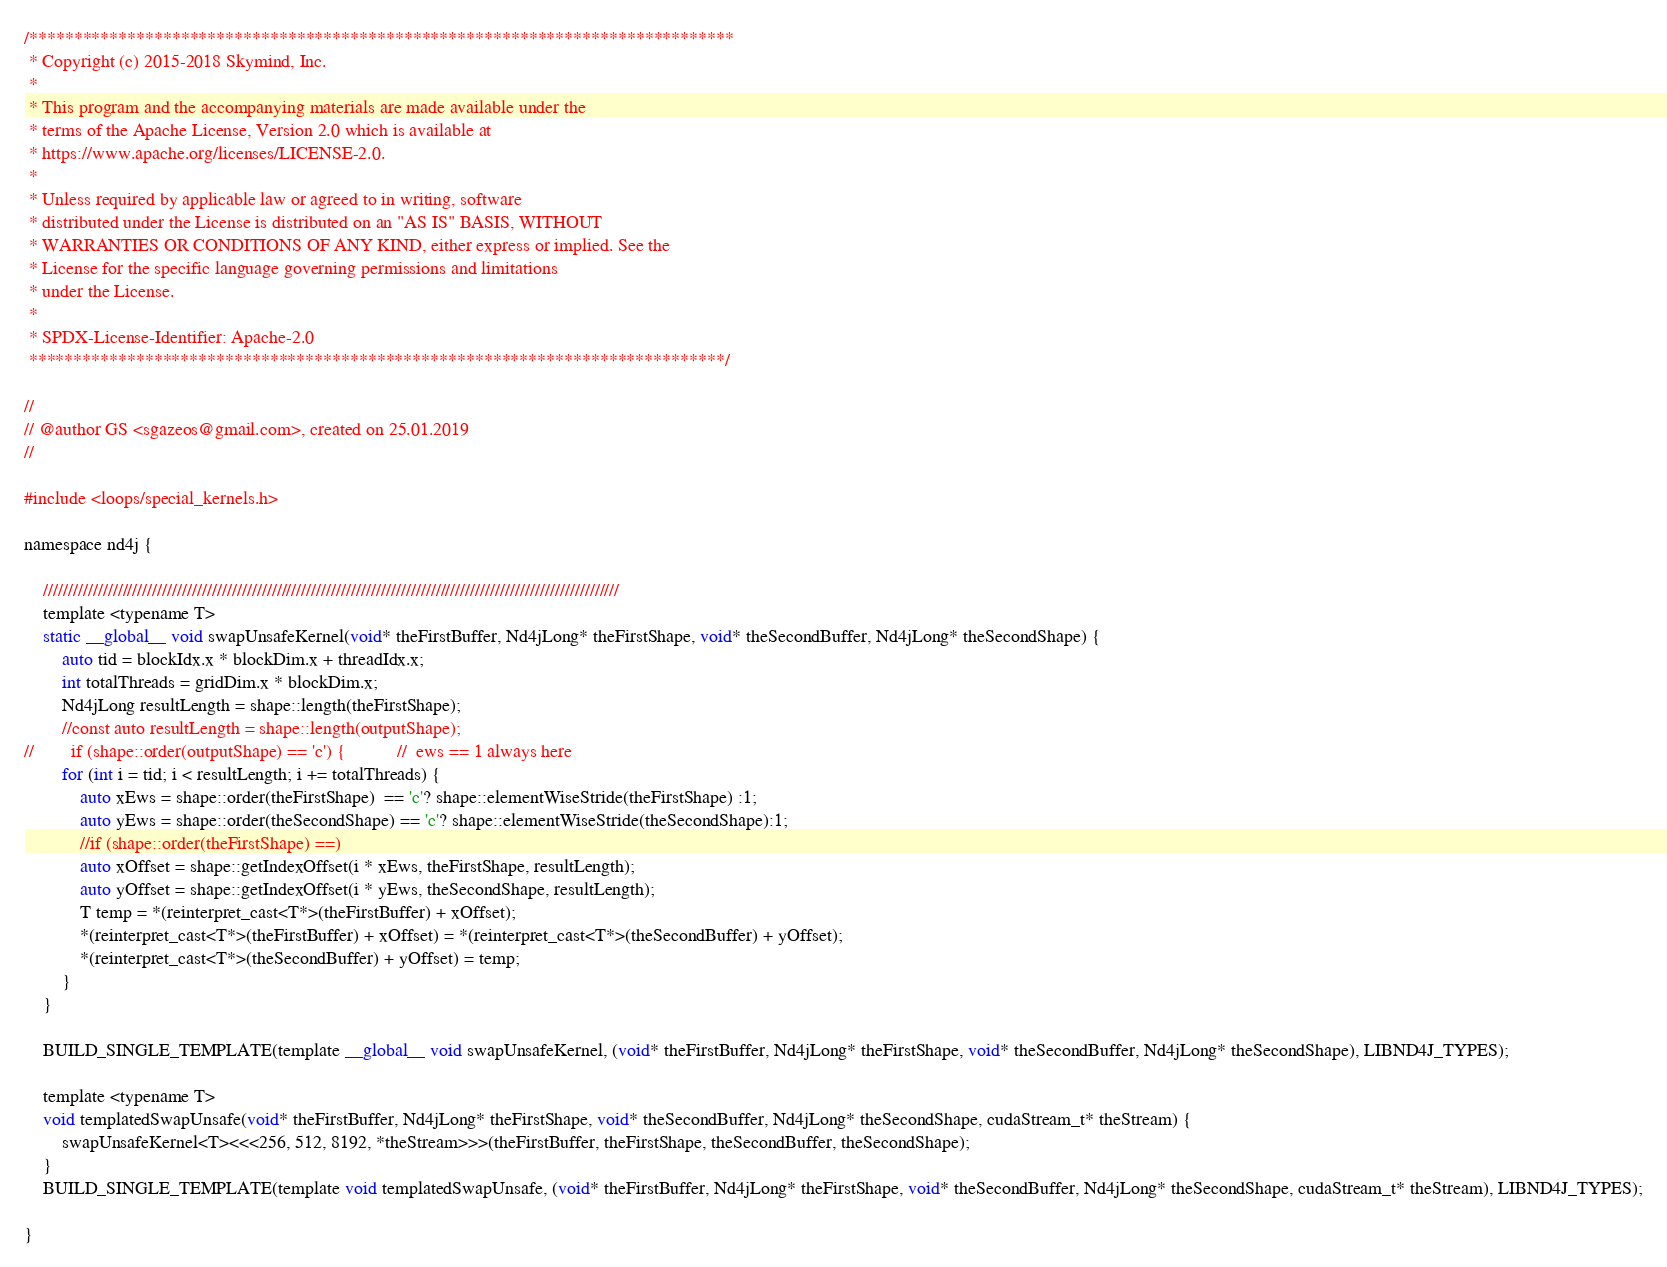<code> <loc_0><loc_0><loc_500><loc_500><_Cuda_>/*******************************************************************************
 * Copyright (c) 2015-2018 Skymind, Inc.
 *
 * This program and the accompanying materials are made available under the
 * terms of the Apache License, Version 2.0 which is available at
 * https://www.apache.org/licenses/LICENSE-2.0.
 *
 * Unless required by applicable law or agreed to in writing, software
 * distributed under the License is distributed on an "AS IS" BASIS, WITHOUT
 * WARRANTIES OR CONDITIONS OF ANY KIND, either express or implied. See the
 * License for the specific language governing permissions and limitations
 * under the License.
 *
 * SPDX-License-Identifier: Apache-2.0
 ******************************************************************************/

//
// @author GS <sgazeos@gmail.com>, created on 25.01.2019
//

#include <loops/special_kernels.h>

namespace nd4j {

    ////////////////////////////////////////////////////////////////////////////////////////////////////////////////////
    template <typename T>
    static __global__ void swapUnsafeKernel(void* theFirstBuffer, Nd4jLong* theFirstShape, void* theSecondBuffer, Nd4jLong* theSecondShape) {
        auto tid = blockIdx.x * blockDim.x + threadIdx.x;
        int totalThreads = gridDim.x * blockDim.x;
        Nd4jLong resultLength = shape::length(theFirstShape);
        //const auto resultLength = shape::length(outputShape);
//        if (shape::order(outputShape) == 'c') {           //  ews == 1 always here
        for (int i = tid; i < resultLength; i += totalThreads) {
            auto xEws = shape::order(theFirstShape)  == 'c'? shape::elementWiseStride(theFirstShape) :1;
            auto yEws = shape::order(theSecondShape) == 'c'? shape::elementWiseStride(theSecondShape):1;
            //if (shape::order(theFirstShape) ==)
            auto xOffset = shape::getIndexOffset(i * xEws, theFirstShape, resultLength);
            auto yOffset = shape::getIndexOffset(i * yEws, theSecondShape, resultLength);
            T temp = *(reinterpret_cast<T*>(theFirstBuffer) + xOffset);
            *(reinterpret_cast<T*>(theFirstBuffer) + xOffset) = *(reinterpret_cast<T*>(theSecondBuffer) + yOffset);
            *(reinterpret_cast<T*>(theSecondBuffer) + yOffset) = temp;
        }
    }

    BUILD_SINGLE_TEMPLATE(template __global__ void swapUnsafeKernel, (void* theFirstBuffer, Nd4jLong* theFirstShape, void* theSecondBuffer, Nd4jLong* theSecondShape), LIBND4J_TYPES);

    template <typename T>
    void templatedSwapUnsafe(void* theFirstBuffer, Nd4jLong* theFirstShape, void* theSecondBuffer, Nd4jLong* theSecondShape, cudaStream_t* theStream) {
        swapUnsafeKernel<T><<<256, 512, 8192, *theStream>>>(theFirstBuffer, theFirstShape, theSecondBuffer, theSecondShape);
    }
    BUILD_SINGLE_TEMPLATE(template void templatedSwapUnsafe, (void* theFirstBuffer, Nd4jLong* theFirstShape, void* theSecondBuffer, Nd4jLong* theSecondShape, cudaStream_t* theStream), LIBND4J_TYPES);

}</code> 